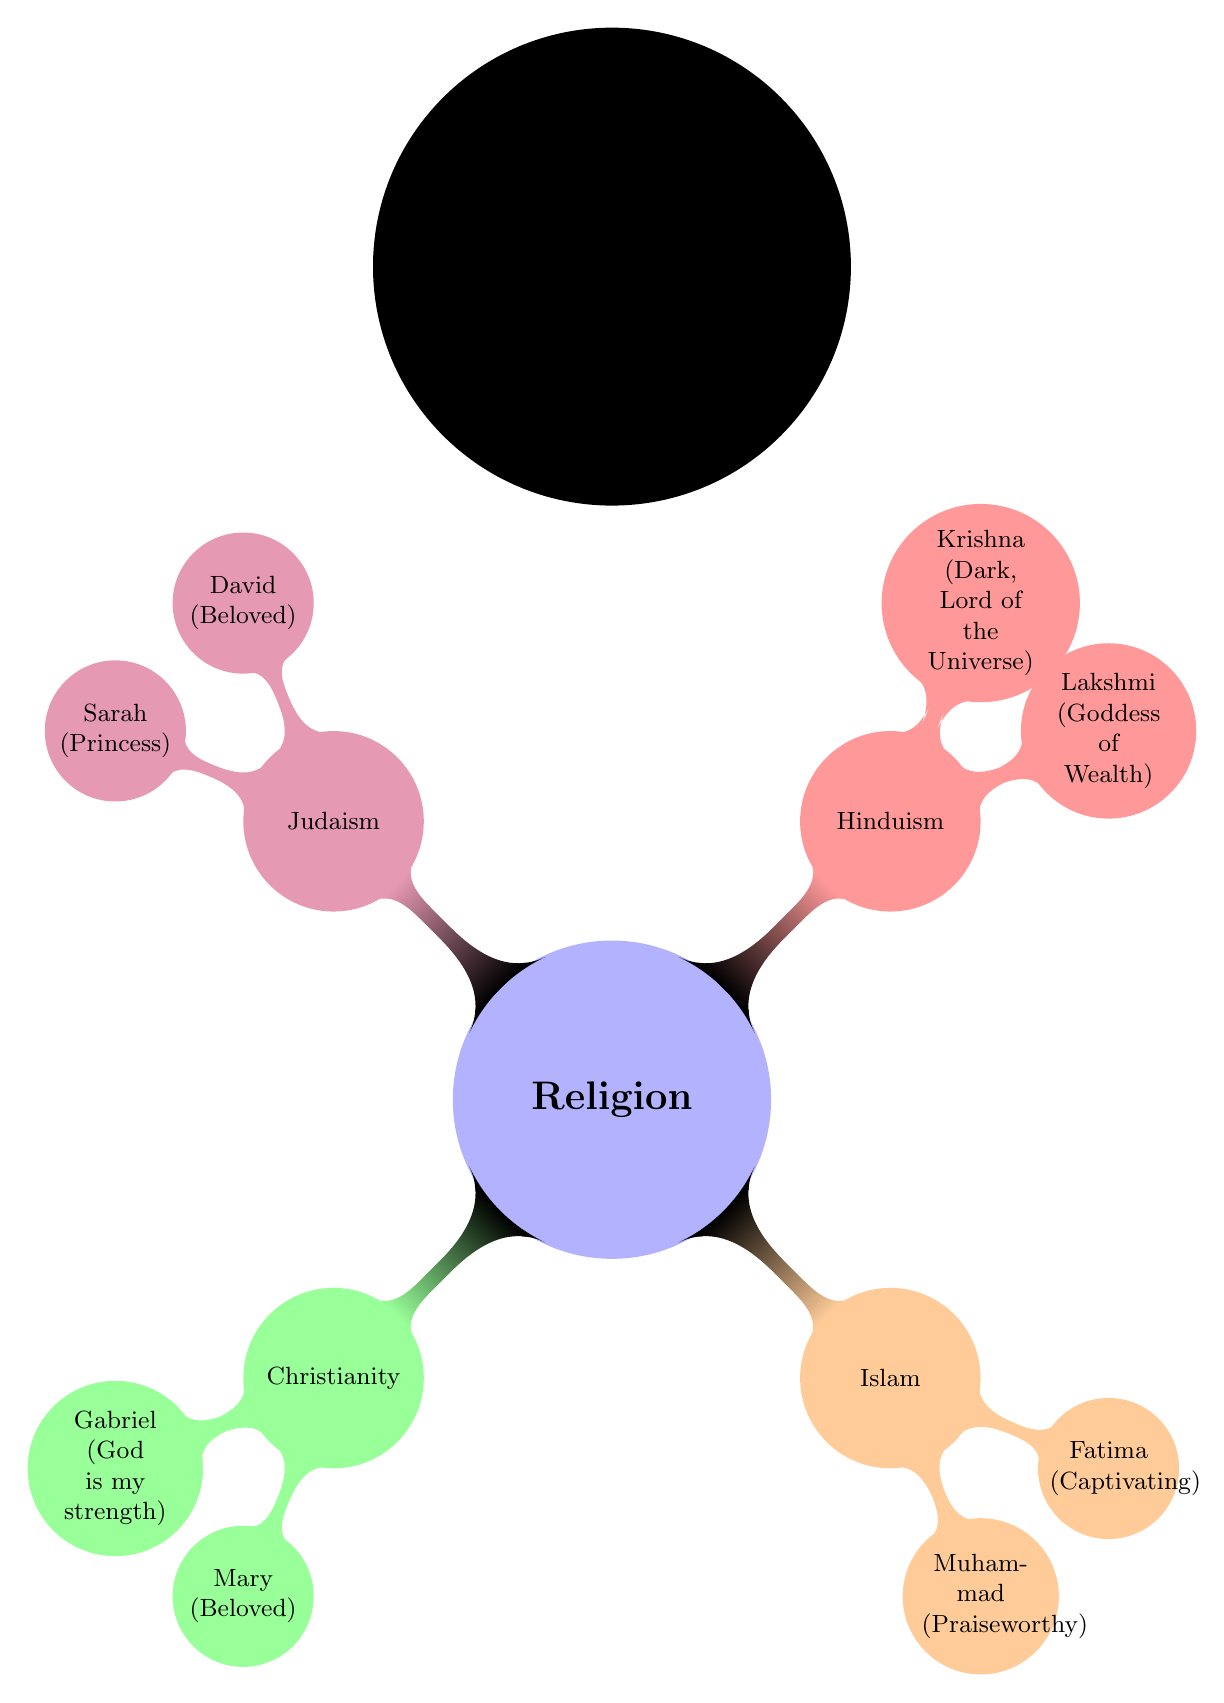What are the names associated with Christianity in this diagram? The diagram shows two names associated with Christianity: Gabriel and Mary. These are found under the Christianity node, which branches from the main Religion node.
Answer: Gabriel, Mary How many names are listed under Hinduism? Under the Hinduism section of the diagram, there are two names listed: Lakshmi and Krishna. Thus, the total is two.
Answer: 2 What does the name Fatima mean? In the diagram, Fatima is defined as "Captivating." This meaning is directly stated next to the name under the Islam section.
Answer: Captivating Which religion features the name Sarah? The name Sarah is featured under the Judaism section of the diagram, which branches from the main Religion node.
Answer: Judaism What is the meaning of the name Lakshmi? The name Lakshmi is denoted as "Goddess of Wealth" in the diagram, which is stated next to the name under the Hinduism section.
Answer: Goddess of Wealth Which name is associated with the descriptor "God is my strength"? The name associated with the meaning "God is my strength" is Gabriel. This is found under the Christianity branch of the diagram.
Answer: Gabriel How many total religious branches are represented in the diagram? The diagram features four distinct religious branches: Christianity, Islam, Hinduism, and Judaism. Therefore, the total count is four.
Answer: 4 Which names are associated with Islam in this diagram? The names associated with Islam according to the diagram are Muhammad and Fatima, both of which are listed under the Islam node.
Answer: Muhammad, Fatima What does the name David signify? David is marked as meaning "Beloved" in the diagram, which is shown under the Judaism section next to the name.
Answer: Beloved 